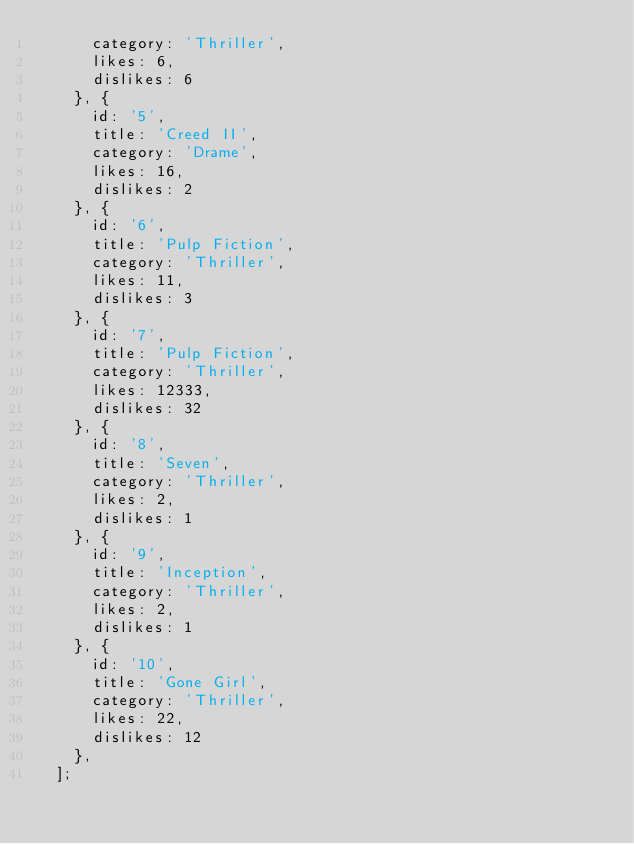Convert code to text. <code><loc_0><loc_0><loc_500><loc_500><_JavaScript_>      category: 'Thriller',
      likes: 6,
      dislikes: 6
    }, {
      id: '5',
      title: 'Creed II',
      category: 'Drame',
      likes: 16,
      dislikes: 2
    }, {
      id: '6',
      title: 'Pulp Fiction',
      category: 'Thriller',
      likes: 11,
      dislikes: 3
    }, {
      id: '7',
      title: 'Pulp Fiction',
      category: 'Thriller',
      likes: 12333,
      dislikes: 32
    }, {
      id: '8',
      title: 'Seven',
      category: 'Thriller',
      likes: 2,
      dislikes: 1
    }, {
      id: '9',
      title: 'Inception',
      category: 'Thriller',
      likes: 2,
      dislikes: 1
    }, {
      id: '10',
      title: 'Gone Girl',
      category: 'Thriller',
      likes: 22,
      dislikes: 12
    },
  ];
  </code> 